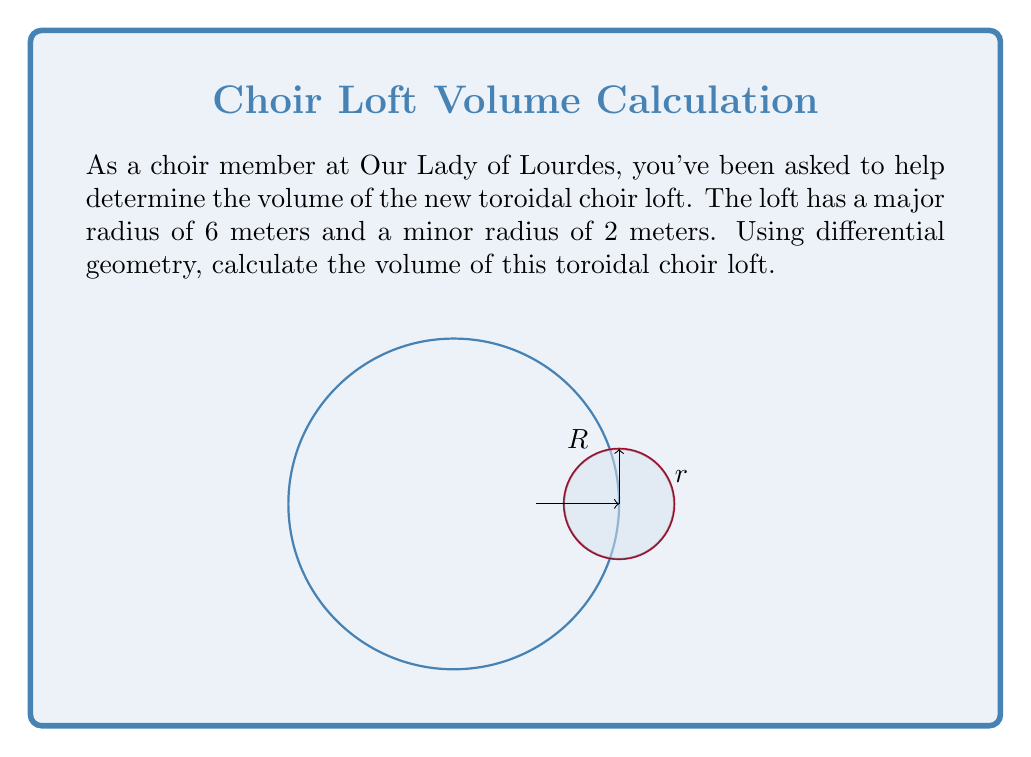Help me with this question. To calculate the volume of a torus using differential geometry, we'll follow these steps:

1) The volume of a torus can be computed using the formula:
   
   $$V = 2\pi^2 R r^2$$

   where $R$ is the major radius and $r$ is the minor radius.

2) This formula comes from integrating the area of the circular cross-section over the path of the major circle:
   
   $$V = \int_0^{2\pi} (\pi r^2) R d\theta$$

3) In our case, we have:
   $R = 6$ meters (major radius)
   $r = 2$ meters (minor radius)

4) Let's substitute these values into our formula:
   
   $$V = 2\pi^2 (6)(2^2)$$

5) Simplify:
   $$V = 2\pi^2 (6)(4)$$
   $$V = 48\pi^2$$

6) If we want to approximate this in cubic meters:
   $$V \approx 48 (3.14159)^2 \approx 474.62 \text{ m}^3$$

Therefore, the volume of the toroidal choir loft is $48\pi^2$ cubic meters, or approximately 474.62 cubic meters.
Answer: $48\pi^2 \text{ m}^3$ 